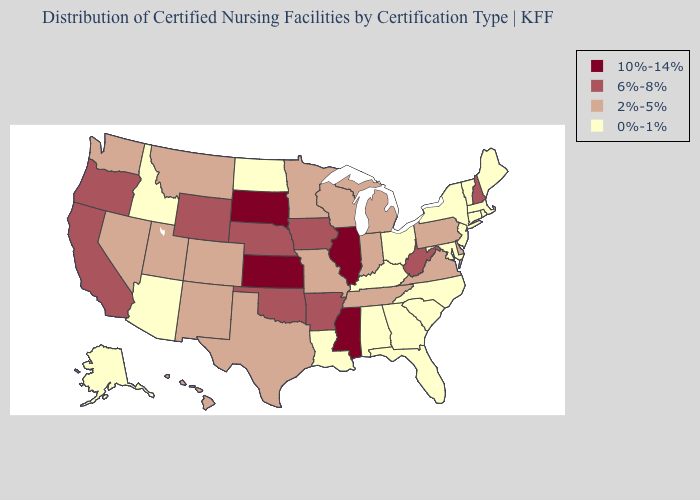What is the highest value in the Northeast ?
Answer briefly. 6%-8%. What is the value of Minnesota?
Concise answer only. 2%-5%. What is the highest value in the USA?
Short answer required. 10%-14%. Among the states that border Missouri , which have the lowest value?
Give a very brief answer. Kentucky. Does Hawaii have the same value as Nevada?
Be succinct. Yes. Name the states that have a value in the range 10%-14%?
Write a very short answer. Illinois, Kansas, Mississippi, South Dakota. Does Kansas have the highest value in the USA?
Be succinct. Yes. Which states have the highest value in the USA?
Be succinct. Illinois, Kansas, Mississippi, South Dakota. Does Kentucky have the same value as Oklahoma?
Keep it brief. No. What is the value of Hawaii?
Keep it brief. 2%-5%. What is the highest value in the USA?
Short answer required. 10%-14%. How many symbols are there in the legend?
Answer briefly. 4. Among the states that border Iowa , which have the lowest value?
Answer briefly. Minnesota, Missouri, Wisconsin. Does the map have missing data?
Give a very brief answer. No. Does Connecticut have the highest value in the USA?
Quick response, please. No. 